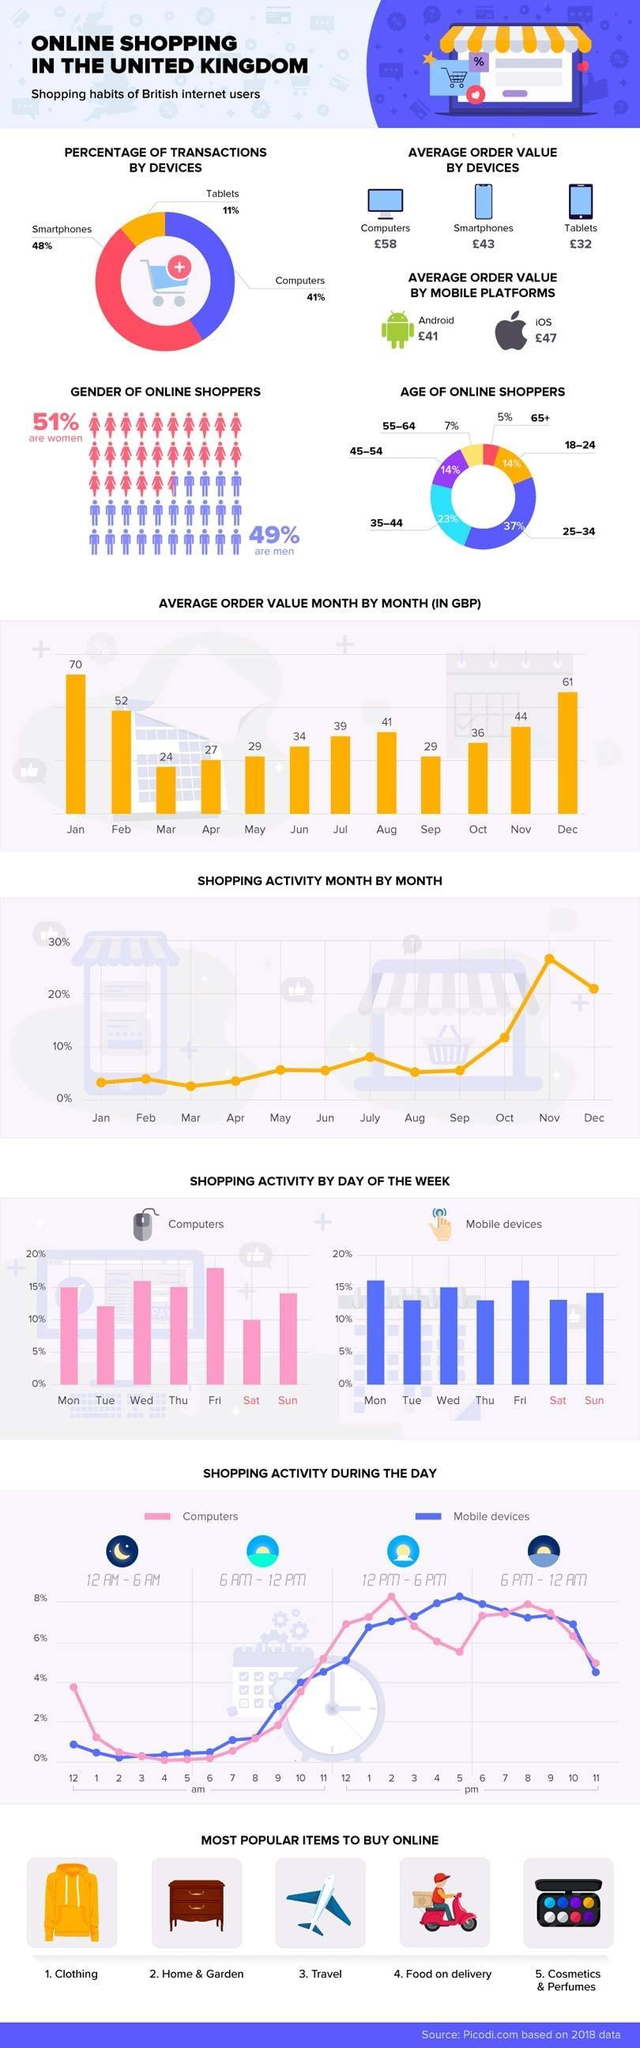What percentage of online shoppers are in the age group of 25-34 in UK in 2018?
Answer the question with a short phrase. 37% What percentage of online transactions in UK are done through computers in 2018? 41% Which month in 2018 shows the second highest average order value (in GBP) in UK? Dec What is the average order value of online shopping done through tablets in UK in 2018? £32 Which age group people in UK are least dependent on online shopping in 2018? 65+ Which month in 2018 shows the highest online shopping percentage in UK? Nov Which device is used by most of the UK people for online transactions  in 2018 ? Smartphones What is the average order value of online shopping done through iOS phones in UK in 2018? £47 What is the average order value (in GBP) in the month of July 2018 in UK? 39 What percentage of online shoppers are in the age group of 18-24 in UK in 2018? 14% 